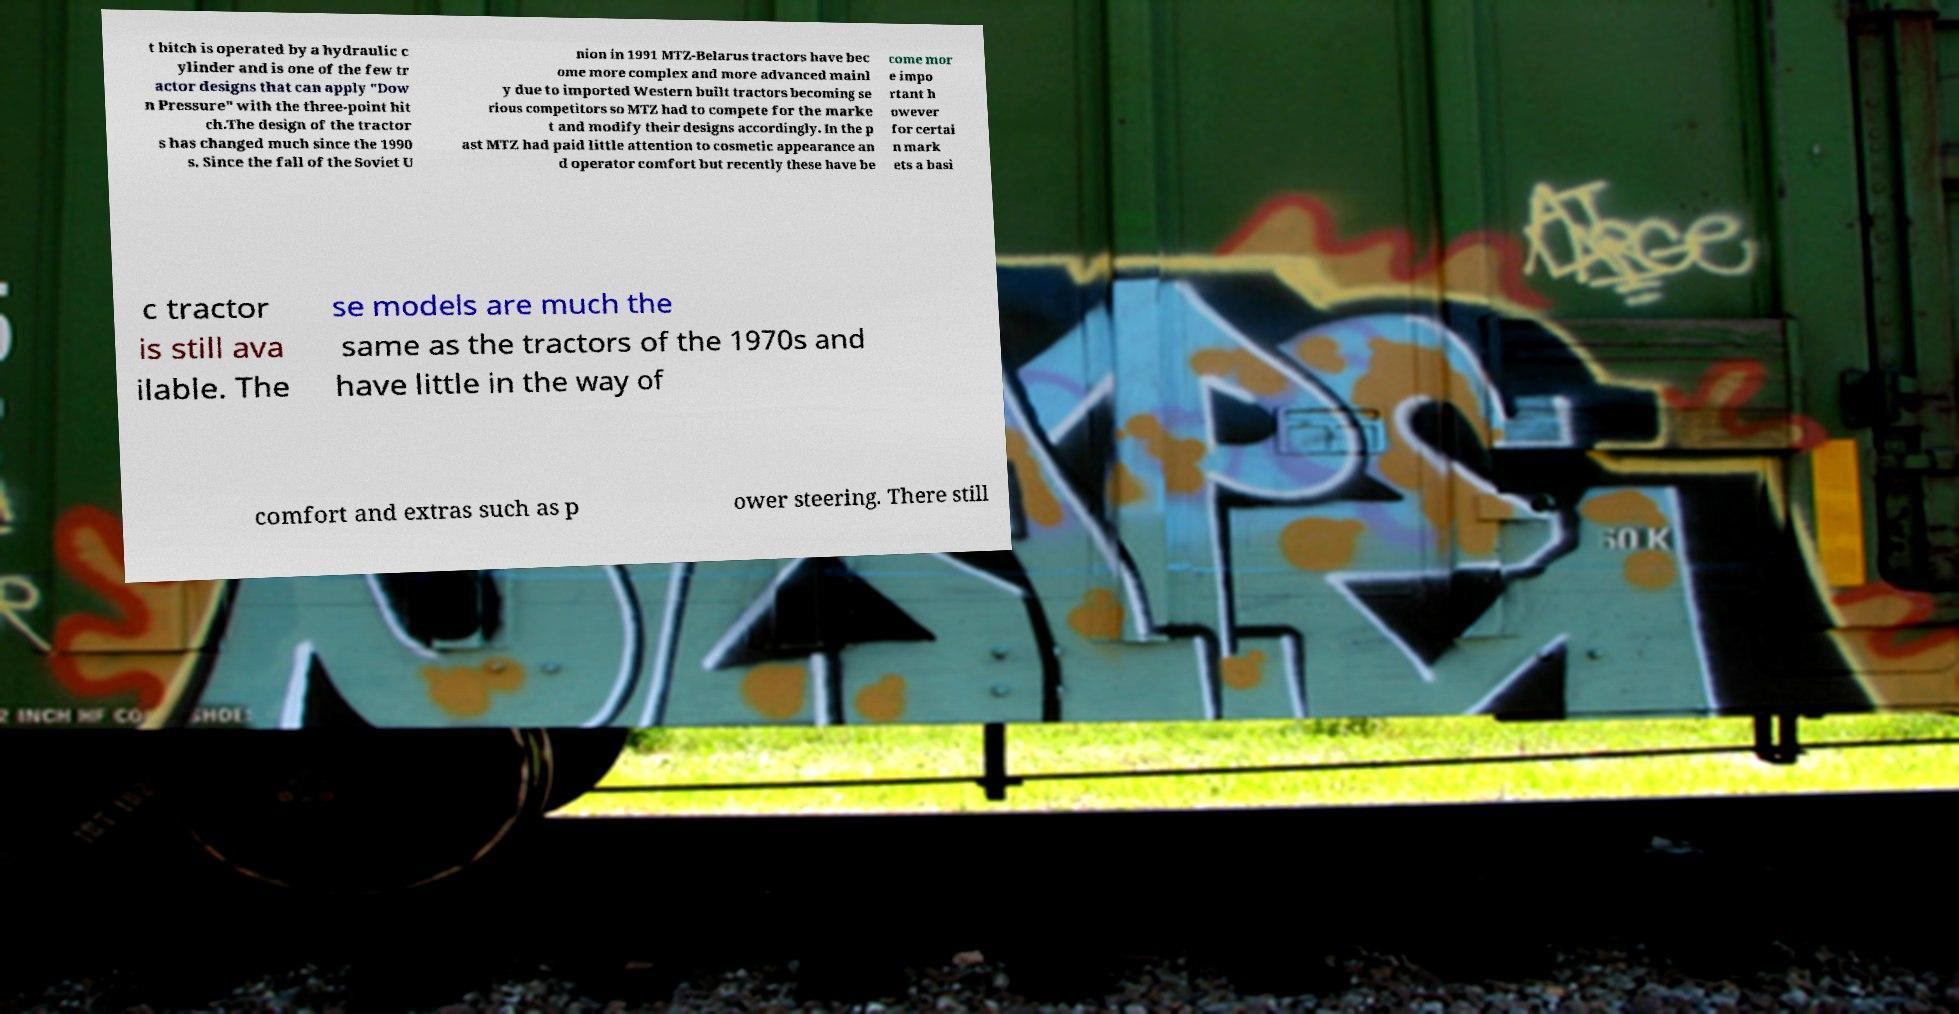What messages or text are displayed in this image? I need them in a readable, typed format. t hitch is operated by a hydraulic c ylinder and is one of the few tr actor designs that can apply "Dow n Pressure" with the three-point hit ch.The design of the tractor s has changed much since the 1990 s. Since the fall of the Soviet U nion in 1991 MTZ-Belarus tractors have bec ome more complex and more advanced mainl y due to imported Western built tractors becoming se rious competitors so MTZ had to compete for the marke t and modify their designs accordingly. In the p ast MTZ had paid little attention to cosmetic appearance an d operator comfort but recently these have be come mor e impo rtant h owever for certai n mark ets a basi c tractor is still ava ilable. The se models are much the same as the tractors of the 1970s and have little in the way of comfort and extras such as p ower steering. There still 